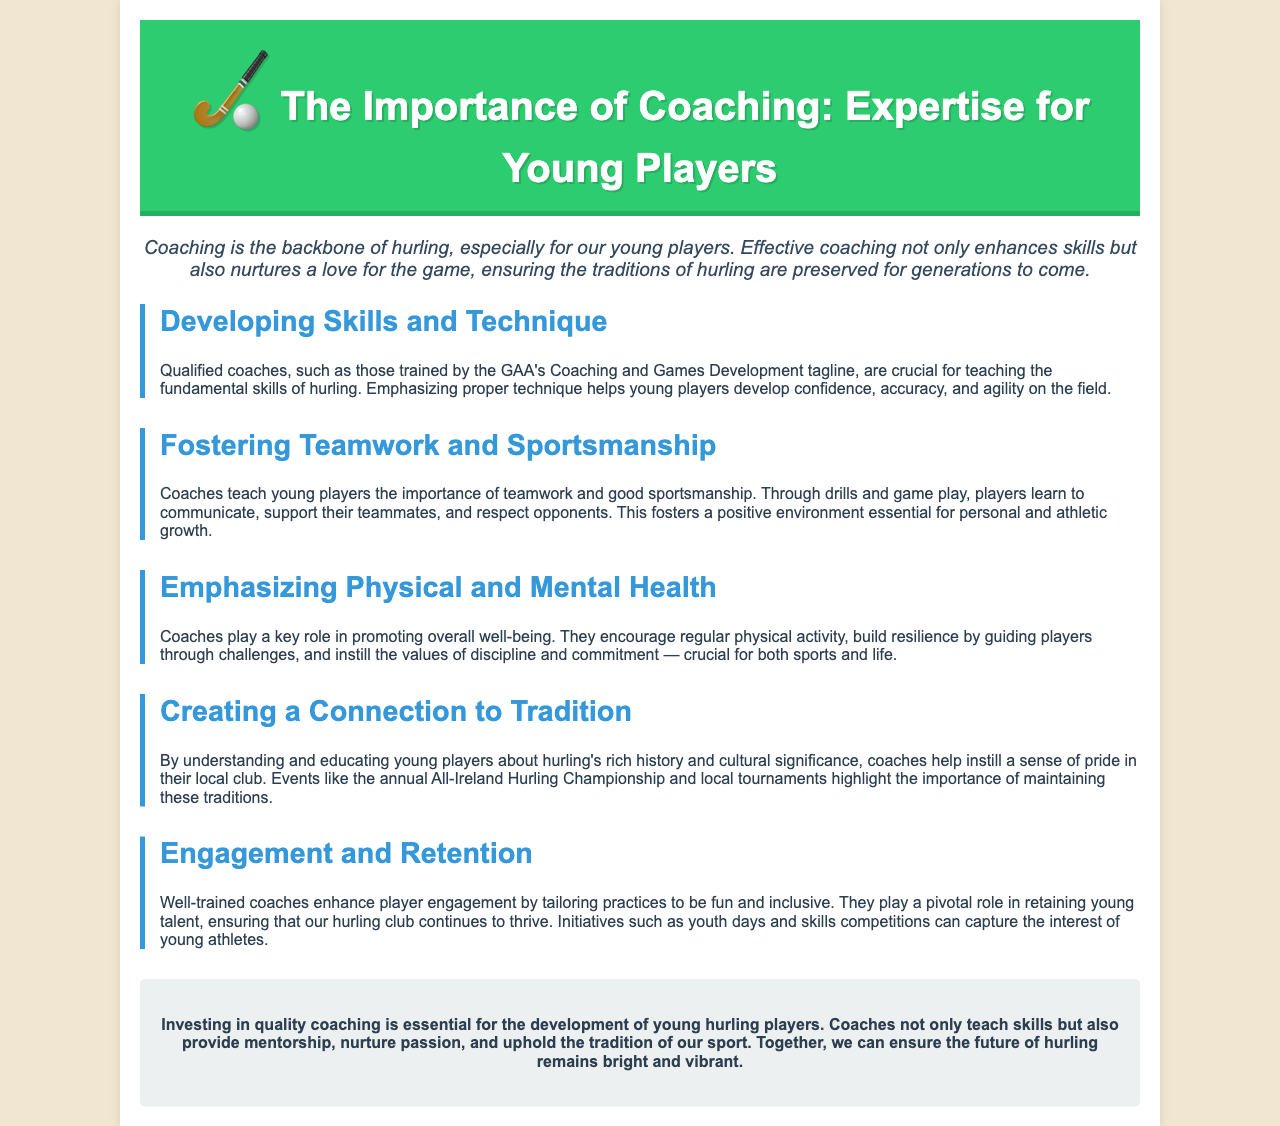What is the main theme of the brochure? The brochure focuses on the importance of coaching for young hurling players, highlighting its impact on skill development and tradition preservation.
Answer: Importance of Coaching Who is responsible for teaching fundamental skills of hurling? The document states that qualified coaches trained by the GAA's Coaching and Games Development are crucial for teaching skills.
Answer: Qualified coaches What does the brochure emphasize regarding physical health? It mentions that coaches encourage regular physical activity and build resilience, which are essential for health.
Answer: Regular physical activity How do coaches contribute to teamwork? Coaches teach young players the importance of teamwork through drills and gameplay, fostering communication and support.
Answer: Teamwork What is one event that helps maintain hurling traditions? The document highlights the annual All-Ireland Hurling Championship as an event that underscores the sport's traditions.
Answer: All-Ireland Hurling Championship Why are well-trained coaches important for player retention? The brochure explains that well-trained coaches tailor practices to be fun and inclusive, enhancing player engagement.
Answer: Fun and inclusive practices How does coaching influence personal growth? Coaches instill values of discipline and commitment, which are crucial for personal growth alongside sports.
Answer: Discipline and commitment What role do coaches play in fostering a positive environment? Coaches help create a positive environment essential for personal and athletic growth through sportsmanship.
Answer: Positive environment 